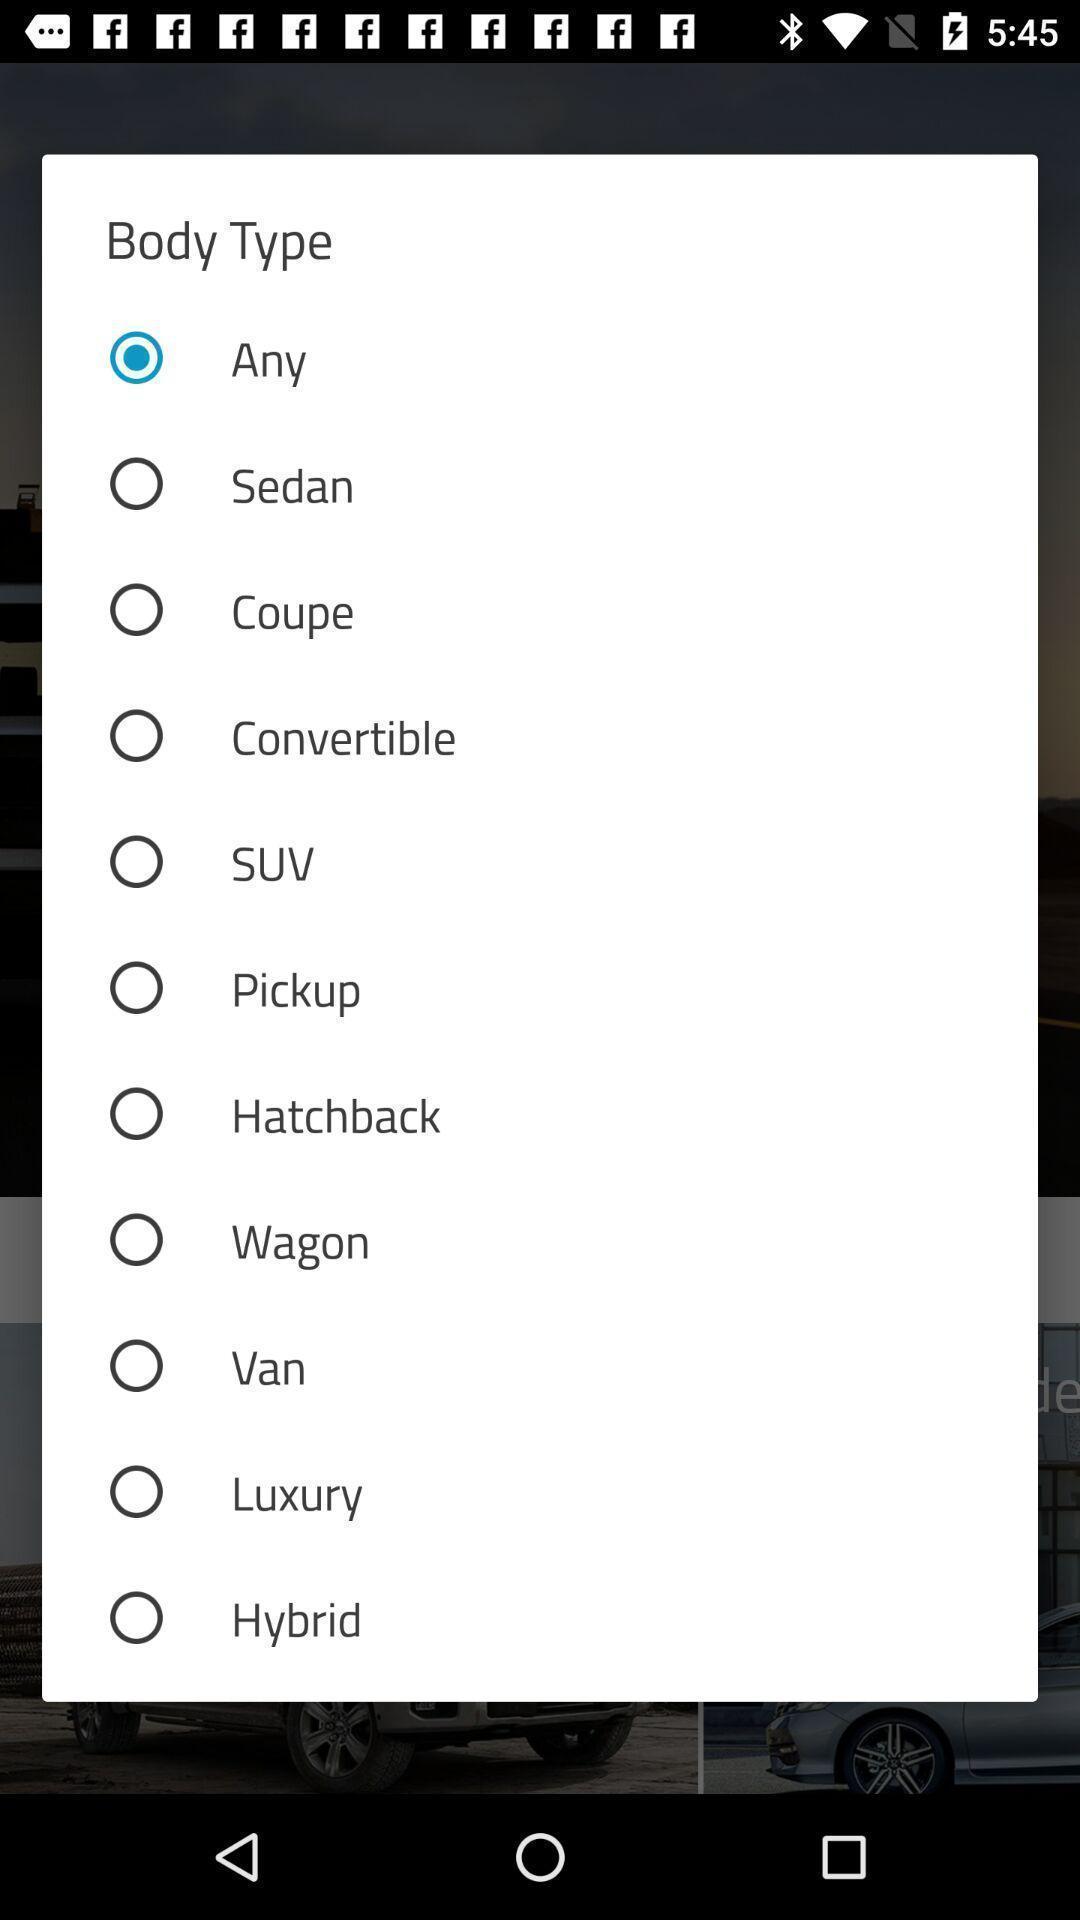Provide a textual representation of this image. Pop-up displays to select body type. 